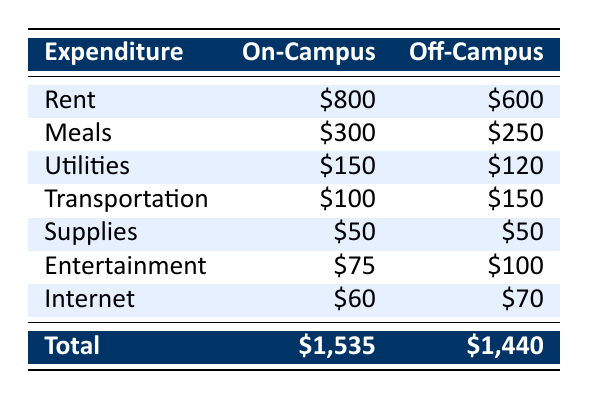What is the total monthly expenditure for on-campus living? The total expenditure for on-campus living is provided directly in the table. It states that the total monthly expenditure for on-campus living is $1,535.
Answer: $1,535 What is the amount spent on meals for off-campus students? The table lists the expenditure for off-campus meals, and it shows that students living off-campus spend $250 on meals per month.
Answer: $250 Is the rent for on-campus living higher than for off-campus living? The table shows that on-campus rent is $800, while off-campus rent is $600. Since $800 is greater than $600, the answer is yes.
Answer: Yes What is the difference in total monthly expenditure between on-campus and off-campus living? From the table, the total monthly expenditure for on-campus living is $1,535 and for off-campus living is $1,440. The difference can be calculated as $1,535 - $1,440 = $95.
Answer: $95 What is the average monthly expenditure on utilities for both living situations? The table shows that on-campus utility expenditure is $150 and off-campus is $120. First, sum these values: $150 + $120 = $270. Then divide by 2 to get the average: $270 / 2 = $135.
Answer: $135 How much more do on-campus students spend on transportation compared to off-campus students? On-campus transportation spending is $100, while off-campus is $150. To find how much more on-campus students spend, we calculate $100 - $150 = -$50, which indicates that on-campus students spend $50 less.
Answer: $50 less Is it true that off-campus students spend more on entertainment than on-campus students? According to the table, off-campus entertainment spending is $100, whereas on-campus entertainment spending is $75. Since $100 is greater than $75, the statement is true.
Answer: True What percentage of their total expenditure do on-campus students spend on internet? The on-campus expenditure on internet is $60, and the total expenditure is $1,535. To find the percentage, calculate ($60 / $1,535) * 100 = approximately 3.90%.
Answer: 3.90% How much do both categories (on-campus and off-campus) spend combined on supplies? The table shows that both on-campus and off-campus students spend $50 on supplies each. Therefore, combined spending is $50 + $50 = $100.
Answer: $100 